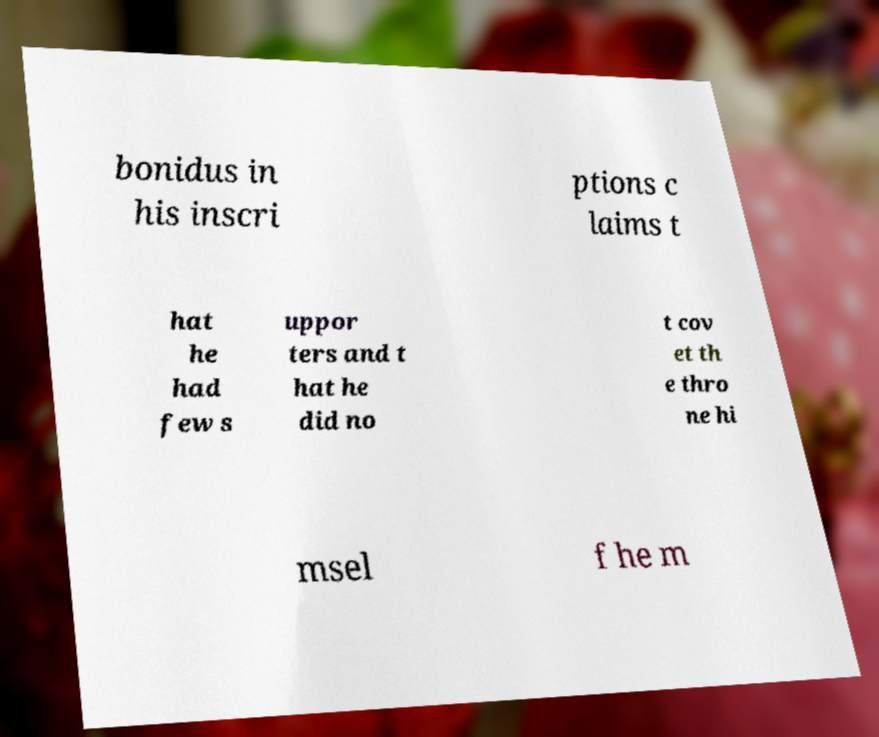Could you extract and type out the text from this image? bonidus in his inscri ptions c laims t hat he had few s uppor ters and t hat he did no t cov et th e thro ne hi msel f he m 